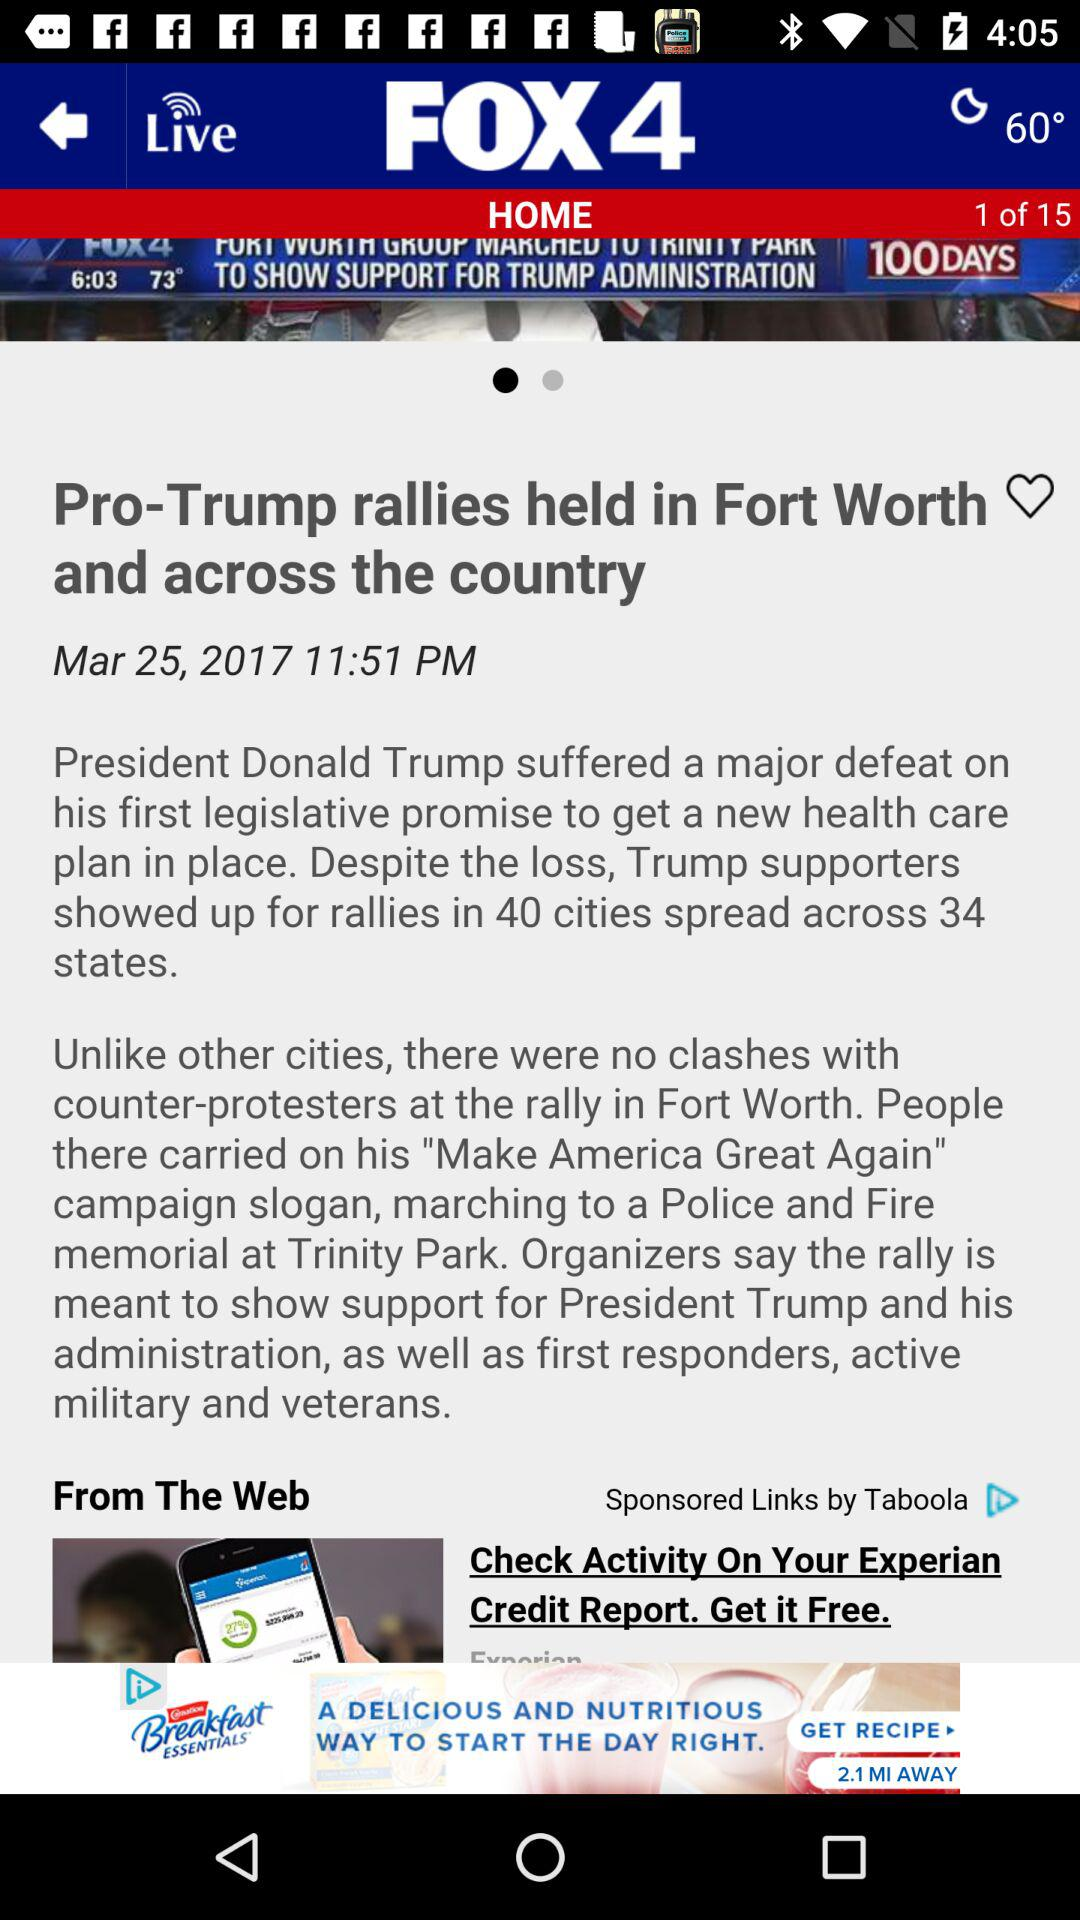What is the temperature shown on the screen? The shown temperature is 60°. 